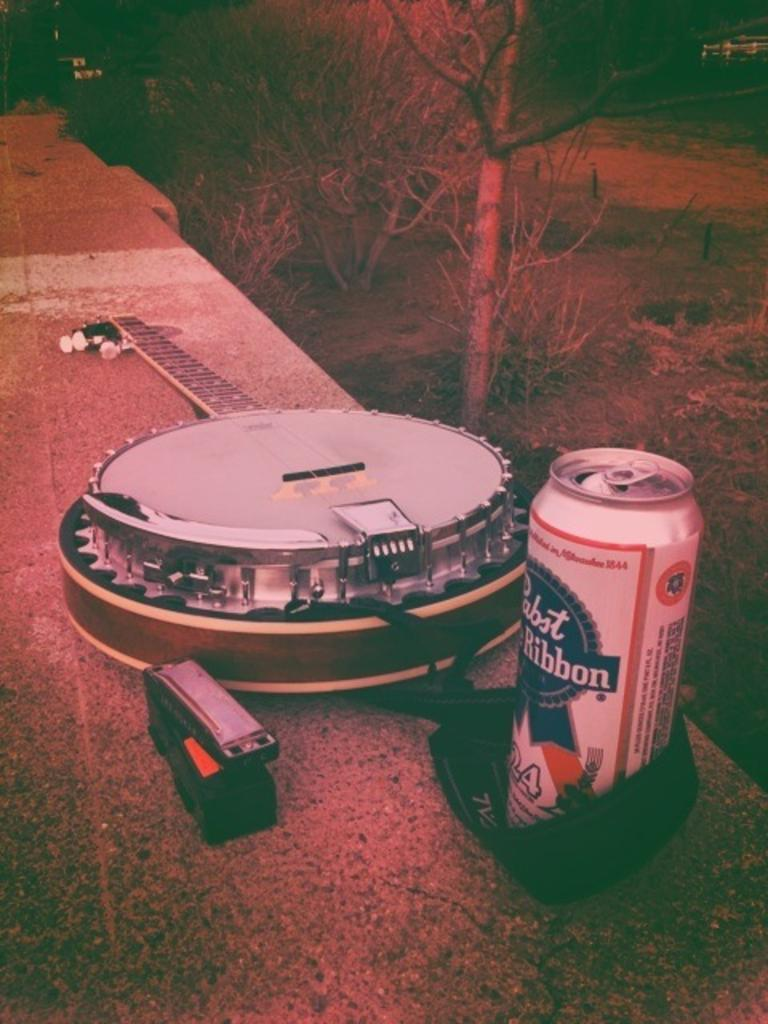<image>
Present a compact description of the photo's key features. Beer and guitar sitting beside each other on a ledge. 